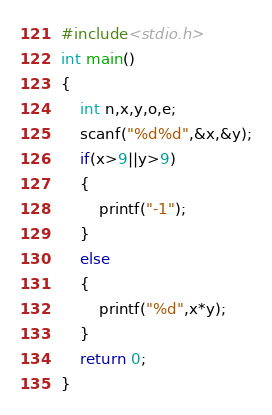Convert code to text. <code><loc_0><loc_0><loc_500><loc_500><_C_>#include<stdio.h>
int main()
{
    int n,x,y,o,e;
    scanf("%d%d",&x,&y);
    if(x>9||y>9)
    {
        printf("-1");
    }
    else
    {
        printf("%d",x*y);
    }
    return 0;
}
</code> 